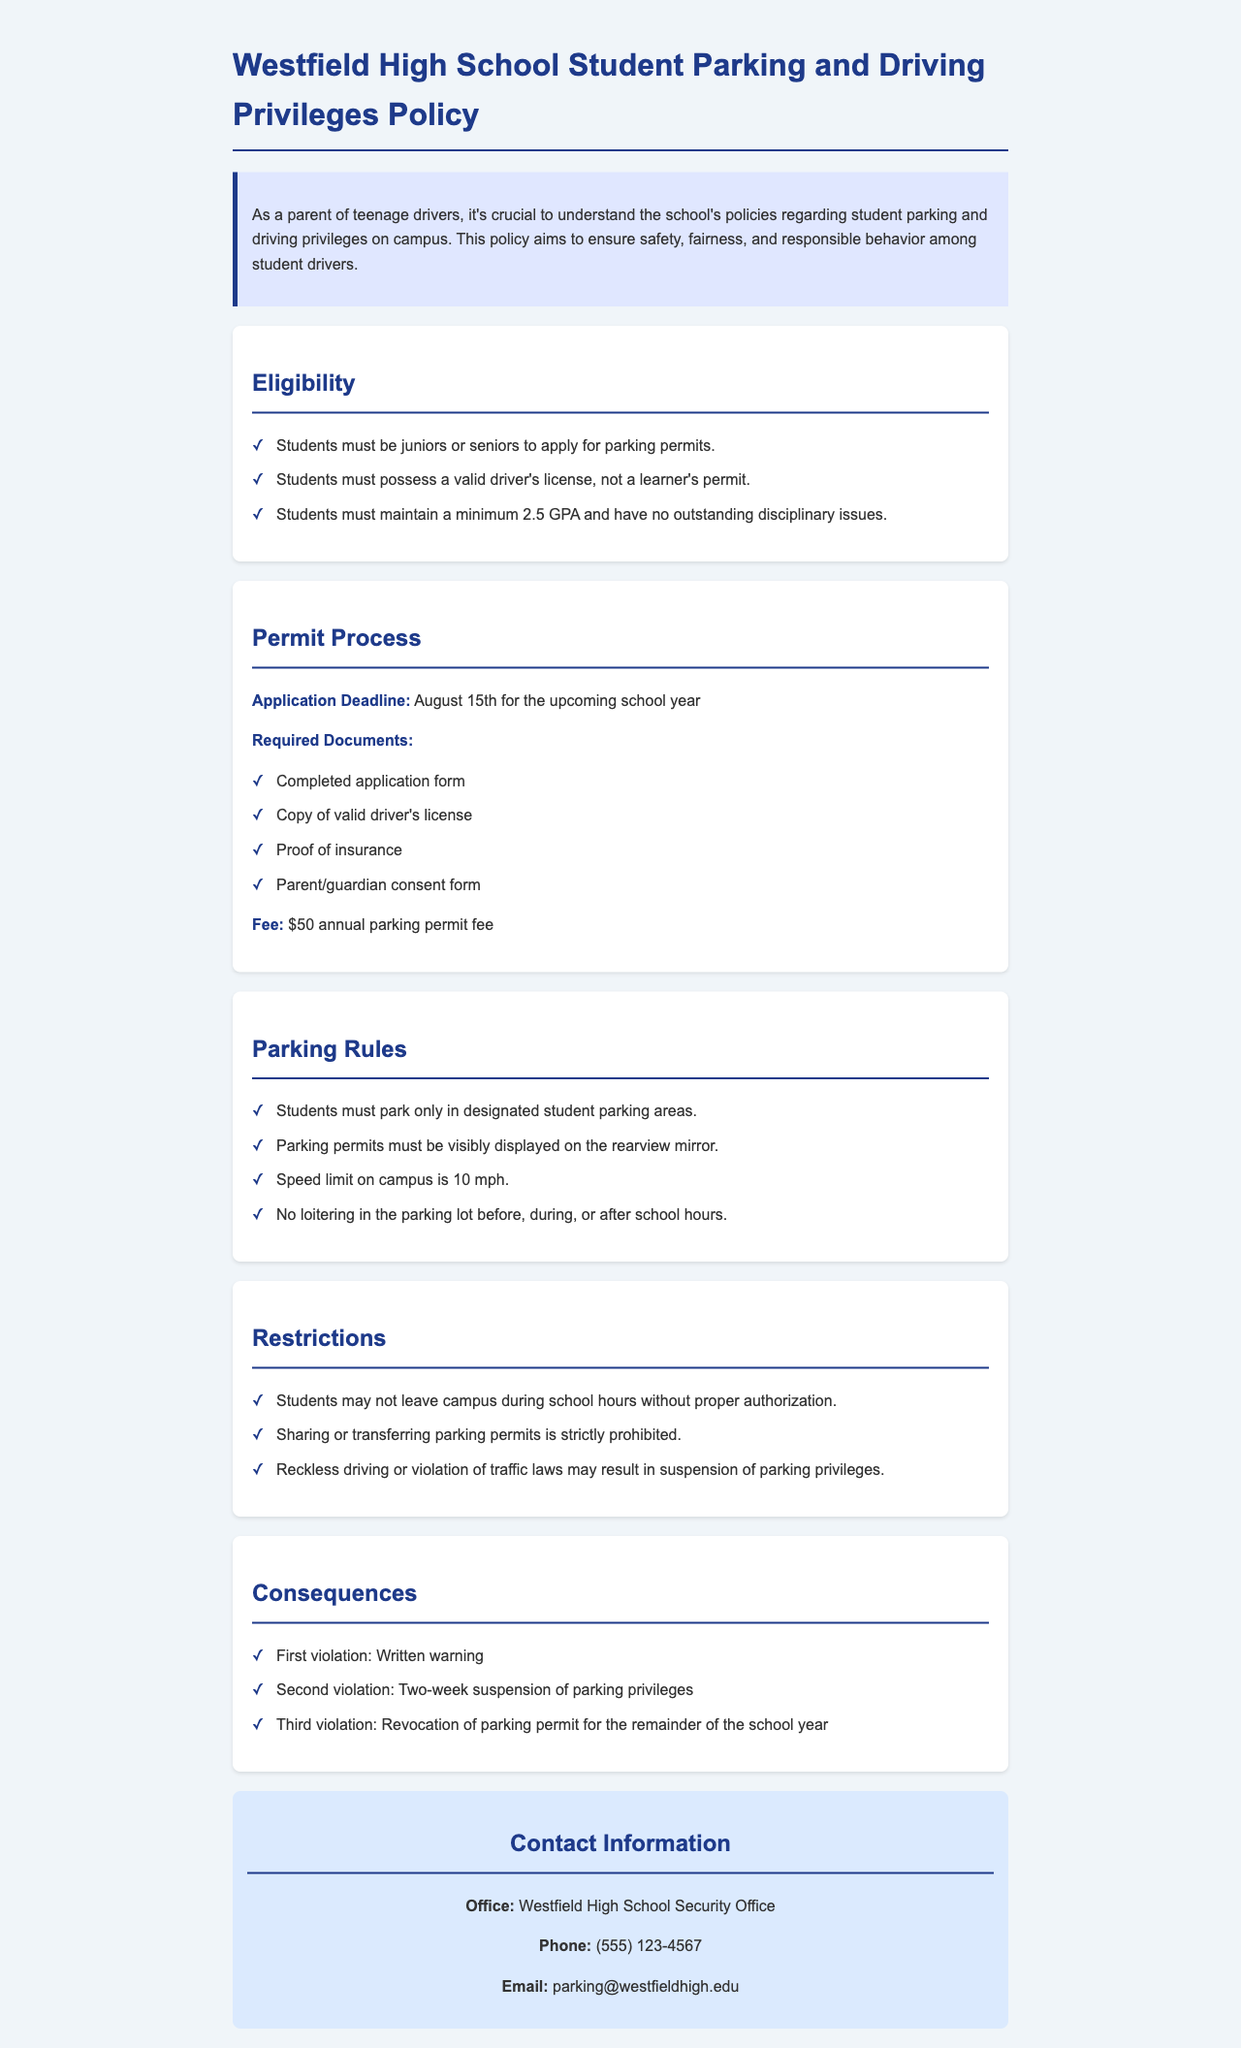What is the minimum GPA required for a parking permit? The document states that students must maintain a minimum 2.5 GPA to be eligible for a parking permit.
Answer: 2.5 GPA What is the annual fee for the parking permit? According to the document, the fee for the parking permit is $50 annually.
Answer: $50 Who must sign the consent form for the parking permit application? The policy outlines that a parent or guardian must sign the consent form required for the parking permit application.
Answer: Parent/guardian What is the consequence of the first violation of parking rules? The document specifies that the first violation results in a written warning.
Answer: Written warning What is the speed limit on campus? The policy states that the speed limit on campus is 10 mph.
Answer: 10 mph What is the application deadline for parking permits? The document indicates that the application deadline is August 15th for the upcoming school year.
Answer: August 15th List one restriction on student parking. The document mentions that students may not leave campus during school hours without proper authorization as one of the restrictions.
Answer: Cannot leave campus What happens after the third violation of parking rules? The document explains that after the third violation, the parking permit is revoked for the remainder of the school year.
Answer: Revocation of parking permit What grades must students be in to apply for a parking permit? The policy states that students must be juniors or seniors to apply for parking permits.
Answer: Juniors or seniors 